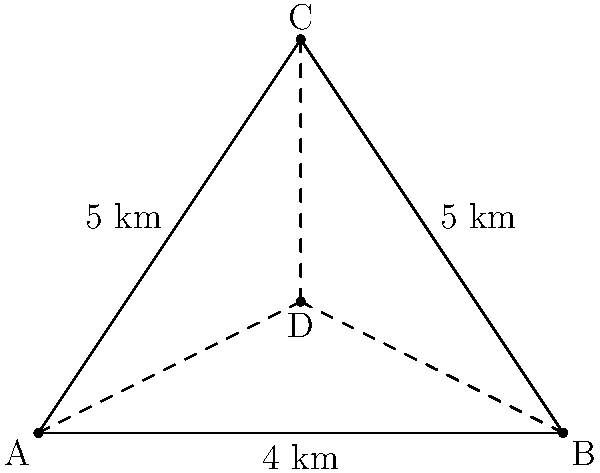As a seasoned politician planning your next campaign, you need to determine the optimal location for your headquarters. Three key voting districts are represented by points A, B, and C on a map, forming a triangle. The distances between these districts are: AB = 8 km, AC = BC = 5 km. You want to place your headquarters at a point D such that the sum of the distances from D to all three districts is minimized. What is the sum of these minimum distances (AD + BD + CD) in kilometers? To solve this problem, we can use the concept of the Fermat point in geometry. The Fermat point of a triangle is the point that minimizes the sum of the distances to the three vertices. Here's how we can approach this:

1) First, we need to determine if any angle of the triangle is greater than or equal to 120°. If so, the Fermat point would be at that vertex.

2) To check this, we can use the cosine law:
   $\cos A = \frac{b^2 + c^2 - a^2}{2bc}$
   where a, b, and c are the side lengths opposite to angles A, B, and C respectively.

3) For angle C:
   $\cos C = \frac{8^2 + 5^2 - 5^2}{2 \cdot 8 \cdot 5} = \frac{89}{80} = 0.55625$

4) $\arccos(0.55625) \approx 56.25°$, which is less than 120°.

5) Due to the symmetry of the triangle, angles A and B will be equal and also less than 120°.

6) Since no angle is greater than or equal to 120°, the Fermat point will be inside the triangle.

7) For an acute triangle, the sum of the distances from the Fermat point to the vertices is given by:
   $AD + BD + CD = \sqrt{(a^2 + b^2 + c^2) + 4\sqrt{3}S}$
   where S is the area of the triangle.

8) We can calculate the area using Heron's formula:
   $S = \sqrt{s(s-a)(s-b)(s-c)}$
   where $s = \frac{a+b+c}{2}$ (semi-perimeter)

9) $s = \frac{8+5+5}{2} = 9$

10) $S = \sqrt{9(9-8)(9-5)(9-5)} = \sqrt{9 \cdot 1 \cdot 4 \cdot 4} = 6$

11) Now we can calculate the sum of distances:
    $AD + BD + CD = \sqrt{(8^2 + 5^2 + 5^2) + 4\sqrt{3} \cdot 6}$
    $= \sqrt{114 + 24\sqrt{3}}$
    $\approx 13.0561$ km

Therefore, the sum of the minimum distances from the optimal headquarters location to all three districts is approximately 13.0561 km.
Answer: $\sqrt{114 + 24\sqrt{3}}$ km $(\approx 13.0561$ km$)$ 